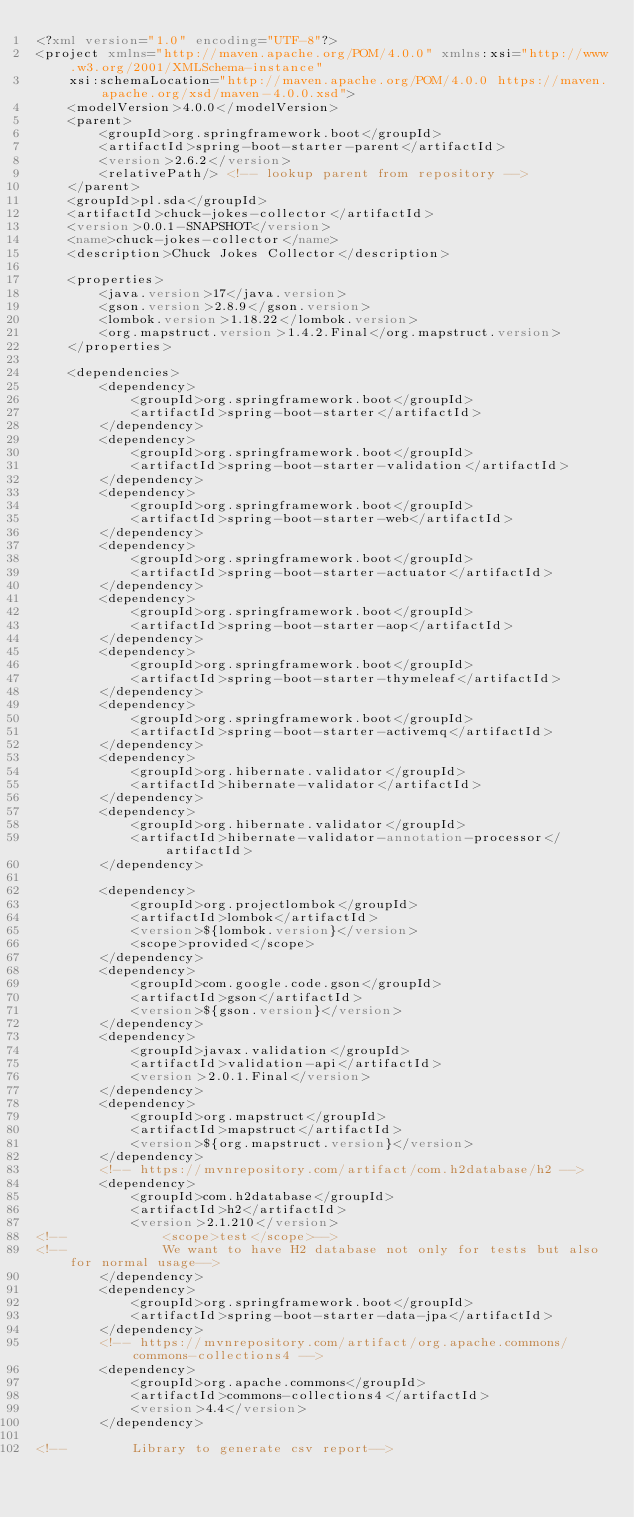<code> <loc_0><loc_0><loc_500><loc_500><_XML_><?xml version="1.0" encoding="UTF-8"?>
<project xmlns="http://maven.apache.org/POM/4.0.0" xmlns:xsi="http://www.w3.org/2001/XMLSchema-instance"
	xsi:schemaLocation="http://maven.apache.org/POM/4.0.0 https://maven.apache.org/xsd/maven-4.0.0.xsd">
	<modelVersion>4.0.0</modelVersion>
	<parent>
		<groupId>org.springframework.boot</groupId>
		<artifactId>spring-boot-starter-parent</artifactId>
		<version>2.6.2</version>
		<relativePath/> <!-- lookup parent from repository -->
	</parent>
	<groupId>pl.sda</groupId>
	<artifactId>chuck-jokes-collector</artifactId>
	<version>0.0.1-SNAPSHOT</version>
	<name>chuck-jokes-collector</name>
	<description>Chuck Jokes Collector</description>

	<properties>
		<java.version>17</java.version>
		<gson.version>2.8.9</gson.version>
		<lombok.version>1.18.22</lombok.version>
		<org.mapstruct.version>1.4.2.Final</org.mapstruct.version>
	</properties>

	<dependencies>
		<dependency>
			<groupId>org.springframework.boot</groupId>
			<artifactId>spring-boot-starter</artifactId>
		</dependency>
		<dependency>
			<groupId>org.springframework.boot</groupId>
			<artifactId>spring-boot-starter-validation</artifactId>
		</dependency>
		<dependency>
			<groupId>org.springframework.boot</groupId>
			<artifactId>spring-boot-starter-web</artifactId>
		</dependency>
		<dependency>
			<groupId>org.springframework.boot</groupId>
			<artifactId>spring-boot-starter-actuator</artifactId>
		</dependency>
		<dependency>
			<groupId>org.springframework.boot</groupId>
			<artifactId>spring-boot-starter-aop</artifactId>
		</dependency>
		<dependency>
			<groupId>org.springframework.boot</groupId>
			<artifactId>spring-boot-starter-thymeleaf</artifactId>
		</dependency>
		<dependency>
			<groupId>org.springframework.boot</groupId>
			<artifactId>spring-boot-starter-activemq</artifactId>
		</dependency>
		<dependency>
			<groupId>org.hibernate.validator</groupId>
			<artifactId>hibernate-validator</artifactId>
		</dependency>
		<dependency>
			<groupId>org.hibernate.validator</groupId>
			<artifactId>hibernate-validator-annotation-processor</artifactId>
		</dependency>

		<dependency>
			<groupId>org.projectlombok</groupId>
			<artifactId>lombok</artifactId>
			<version>${lombok.version}</version>
			<scope>provided</scope>
		</dependency>
		<dependency>
			<groupId>com.google.code.gson</groupId>
			<artifactId>gson</artifactId>
			<version>${gson.version}</version>
		</dependency>
		<dependency>
			<groupId>javax.validation</groupId>
			<artifactId>validation-api</artifactId>
			<version>2.0.1.Final</version>
		</dependency>
		<dependency>
			<groupId>org.mapstruct</groupId>
			<artifactId>mapstruct</artifactId>
			<version>${org.mapstruct.version}</version>
		</dependency>
		<!-- https://mvnrepository.com/artifact/com.h2database/h2 -->
		<dependency>
			<groupId>com.h2database</groupId>
			<artifactId>h2</artifactId>
			<version>2.1.210</version>
<!--			<scope>test</scope>-->
<!--			We want to have H2 database not only for tests but also for normal usage-->
		</dependency>
        <dependency>
            <groupId>org.springframework.boot</groupId>
            <artifactId>spring-boot-starter-data-jpa</artifactId>
        </dependency>
		<!-- https://mvnrepository.com/artifact/org.apache.commons/commons-collections4 -->
		<dependency>
			<groupId>org.apache.commons</groupId>
			<artifactId>commons-collections4</artifactId>
			<version>4.4</version>
		</dependency>

<!--		Library to generate csv report--></code> 